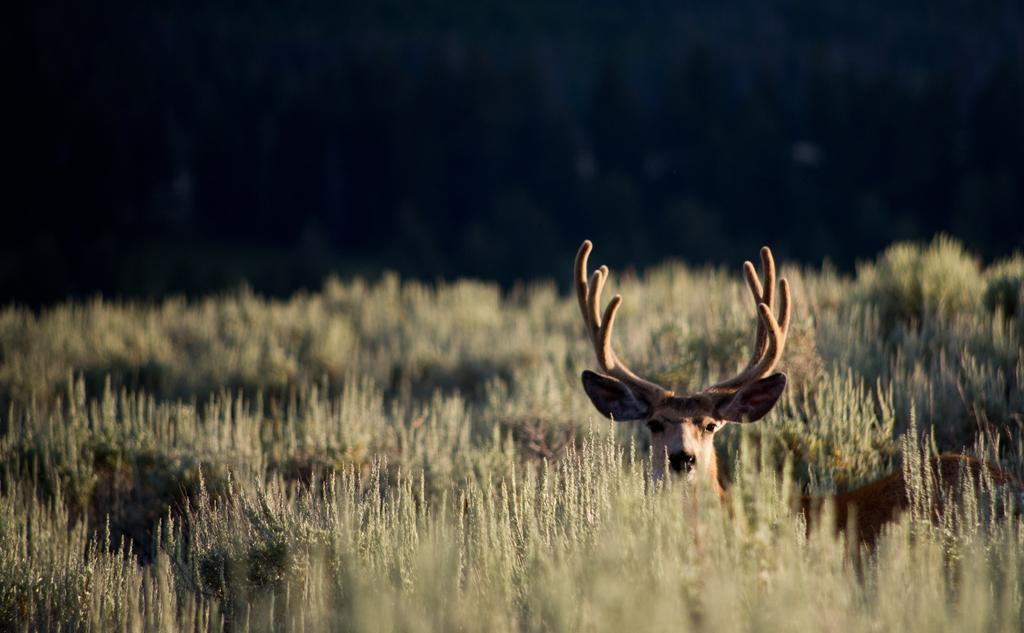What type of living organisms can be seen in the image? Plants and a deer are visible in the image. What is the color of the deer in the image? The deer is brown in color. Where is the deer located in the image? The deer is on the ground in the image. What can be seen in the background of the image? There are trees in the background of the image. How many hands are holding the umbrella in the image? There is no umbrella present in the image, so it is not possible to determine how many hands might be holding it. 